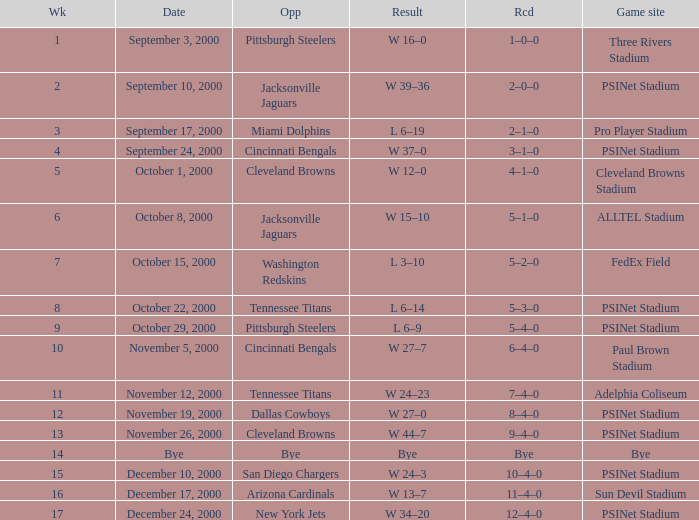What's the record after week 16? 12–4–0. 